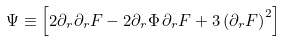<formula> <loc_0><loc_0><loc_500><loc_500>\Psi \equiv \left [ 2 \partial _ { r } \partial _ { r } F - 2 \partial _ { r } \Phi \, \partial _ { r } F + 3 \left ( \partial _ { r } F \right ) ^ { 2 } \right ]</formula> 